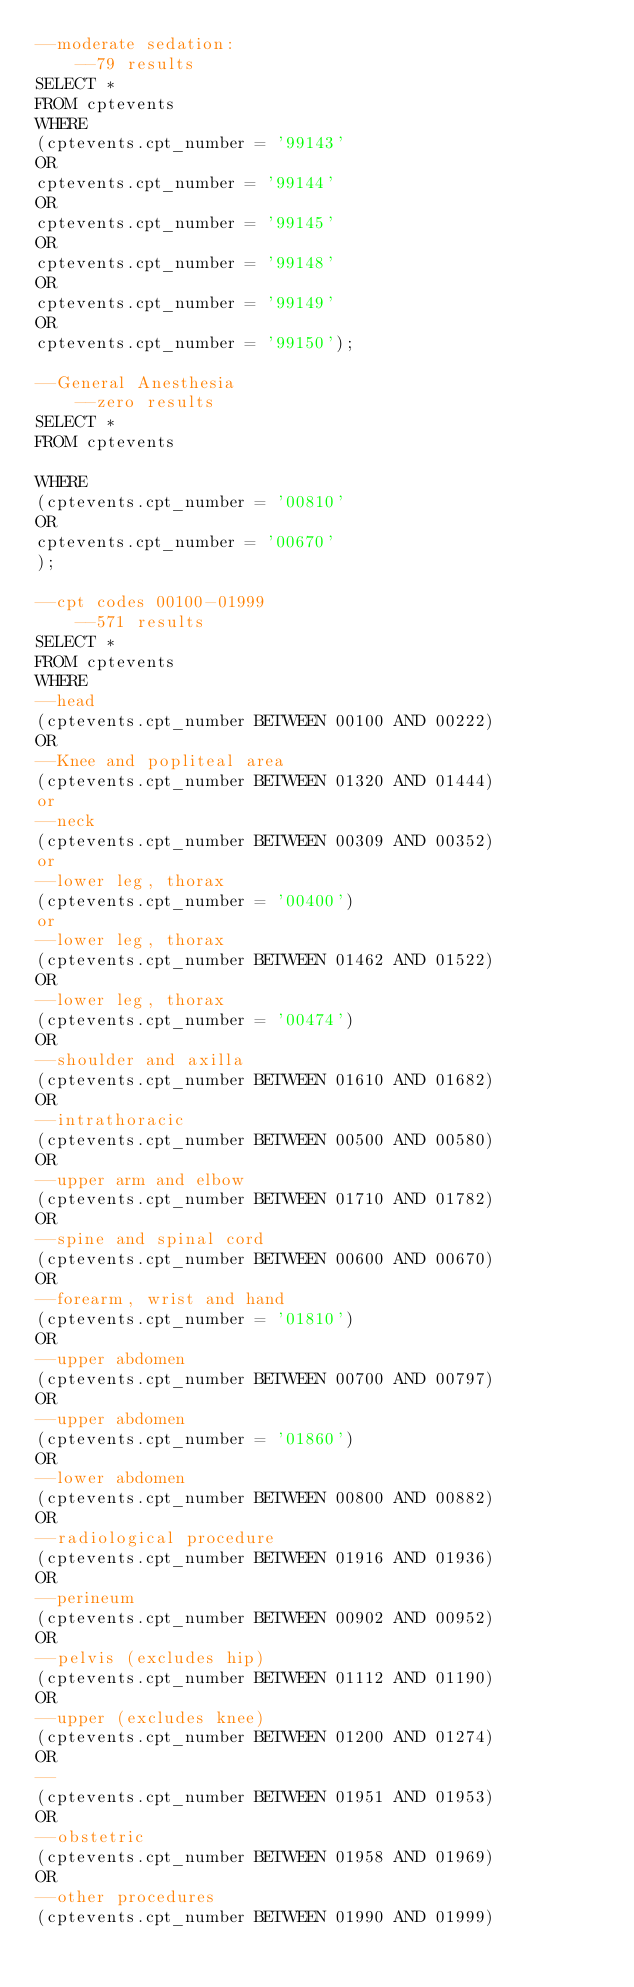<code> <loc_0><loc_0><loc_500><loc_500><_SQL_>--moderate sedation:
    --79 results
SELECT *
FROM cptevents
WHERE 
(cptevents.cpt_number = '99143' 
OR
cptevents.cpt_number = '99144'
OR 
cptevents.cpt_number = '99145'
OR
cptevents.cpt_number = '99148'
OR
cptevents.cpt_number = '99149'
OR
cptevents.cpt_number = '99150');

--General Anesthesia
    --zero results
SELECT *
FROM cptevents

WHERE 
(cptevents.cpt_number = '00810' 
OR
cptevents.cpt_number = '00670'
);

--cpt codes 00100-01999
    --571 results
SELECT *
FROM cptevents
WHERE 
--head
(cptevents.cpt_number BETWEEN 00100 AND 00222) 
OR
--Knee and popliteal area
(cptevents.cpt_number BETWEEN 01320 AND 01444)
or
--neck
(cptevents.cpt_number BETWEEN 00309 AND 00352)
or
--lower leg, thorax
(cptevents.cpt_number = '00400')
or
--lower leg, thorax
(cptevents.cpt_number BETWEEN 01462 AND 01522)
OR
--lower leg, thorax
(cptevents.cpt_number = '00474')
OR
--shoulder and axilla
(cptevents.cpt_number BETWEEN 01610 AND 01682)
OR
--intrathoracic
(cptevents.cpt_number BETWEEN 00500 AND 00580)
OR
--upper arm and elbow
(cptevents.cpt_number BETWEEN 01710 AND 01782)
OR 
--spine and spinal cord
(cptevents.cpt_number BETWEEN 00600 AND 00670)
OR 
--forearm, wrist and hand
(cptevents.cpt_number = '01810')
OR
--upper abdomen
(cptevents.cpt_number BETWEEN 00700 AND 00797)
OR 
--upper abdomen
(cptevents.cpt_number = '01860')
OR
--lower abdomen
(cptevents.cpt_number BETWEEN 00800 AND 00882)
OR 
--radiological procedure
(cptevents.cpt_number BETWEEN 01916 AND 01936)
OR
--perineum
(cptevents.cpt_number BETWEEN 00902 AND 00952) 
OR
--pelvis (excludes hip)
(cptevents.cpt_number BETWEEN 01112 AND 01190)
OR
--upper (excludes knee)
(cptevents.cpt_number BETWEEN 01200 AND 01274)
OR
--
(cptevents.cpt_number BETWEEN 01951 AND 01953)
OR
--obstetric
(cptevents.cpt_number BETWEEN 01958 AND 01969)
OR
--other procedures
(cptevents.cpt_number BETWEEN 01990 AND 01999)
 </code> 